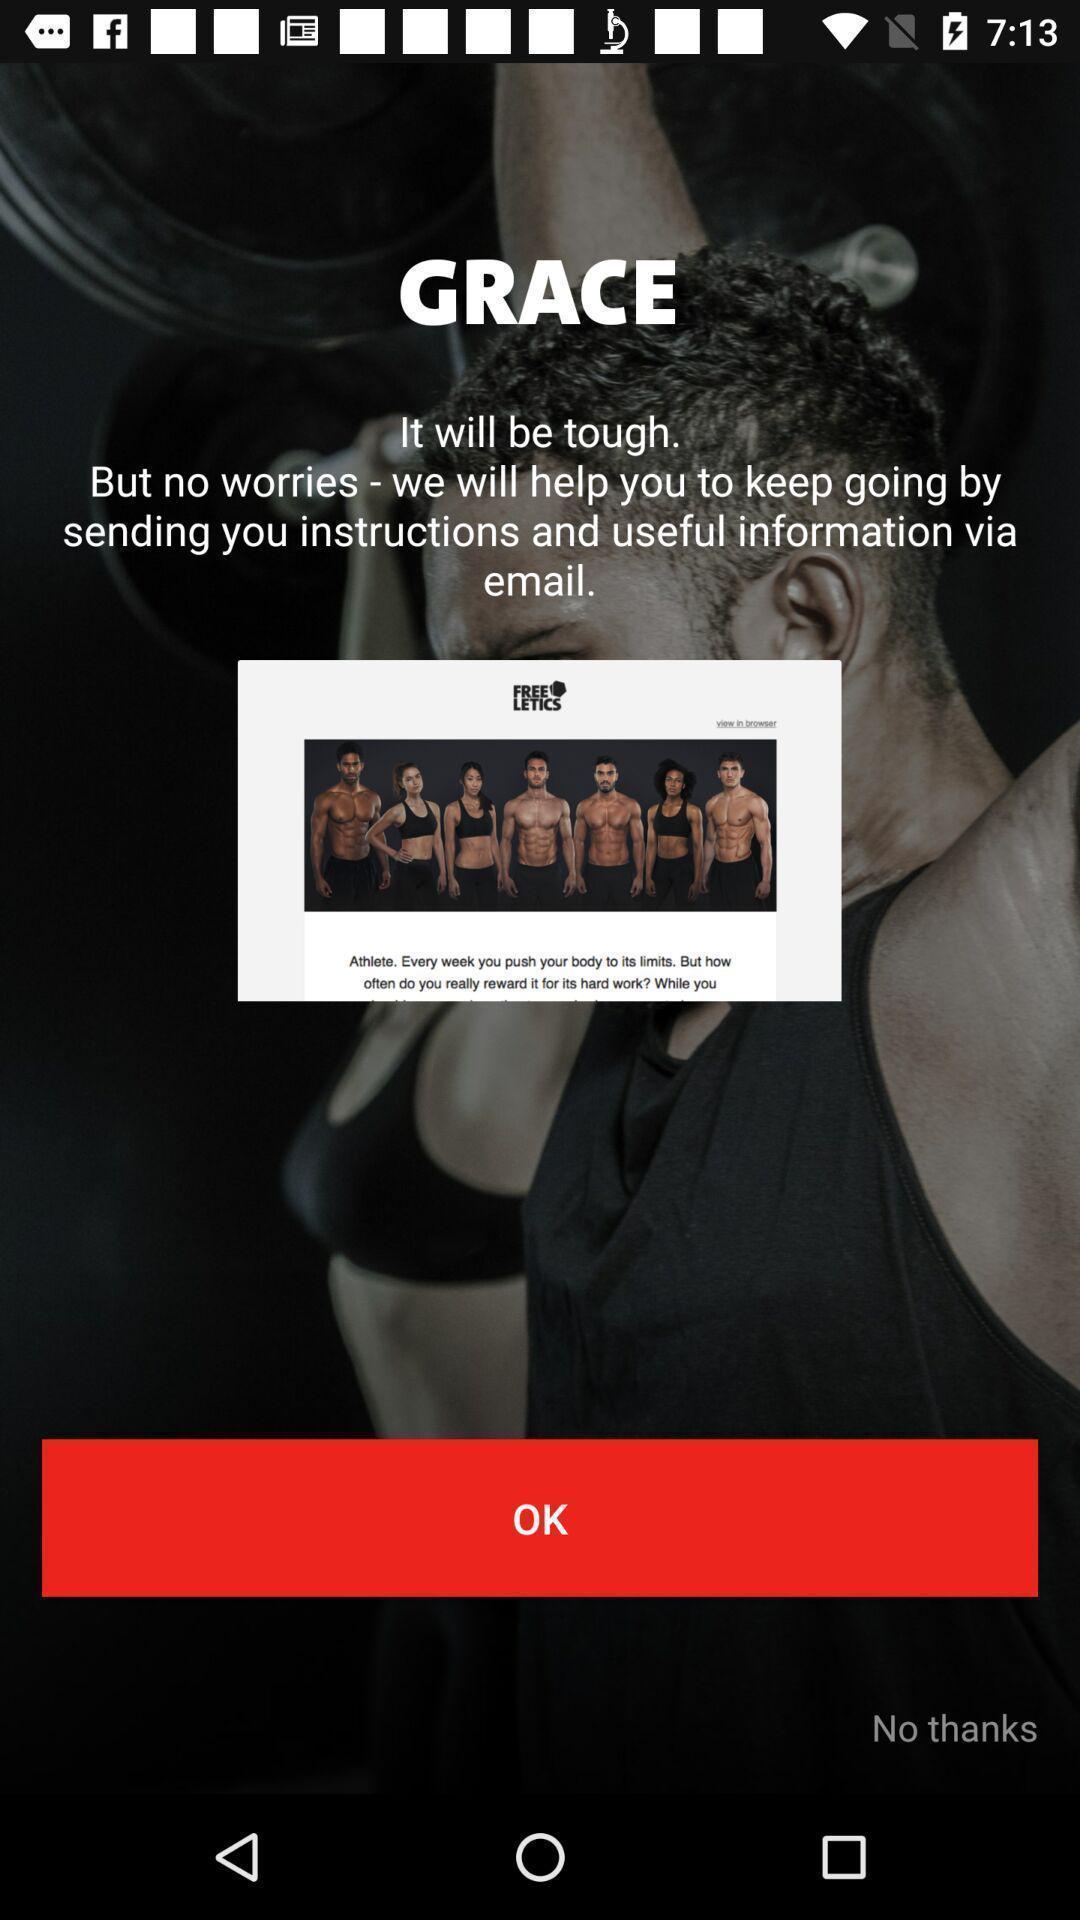What is the overall content of this screenshot? Welcome page of fitness application. 